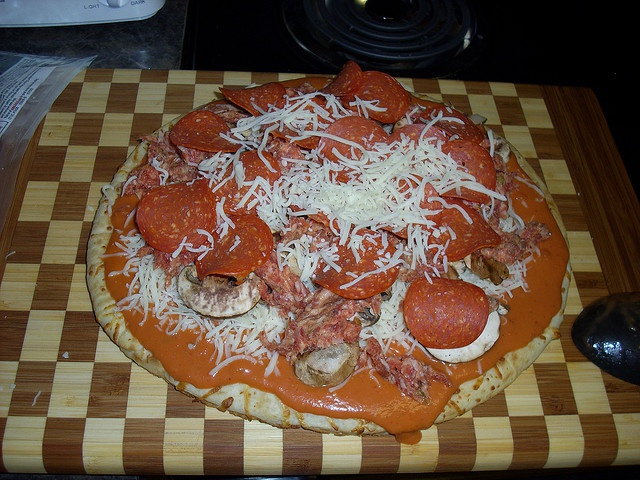Describe the objects in this image and their specific colors. I can see a pizza in blue, maroon, darkgray, and brown tones in this image. 